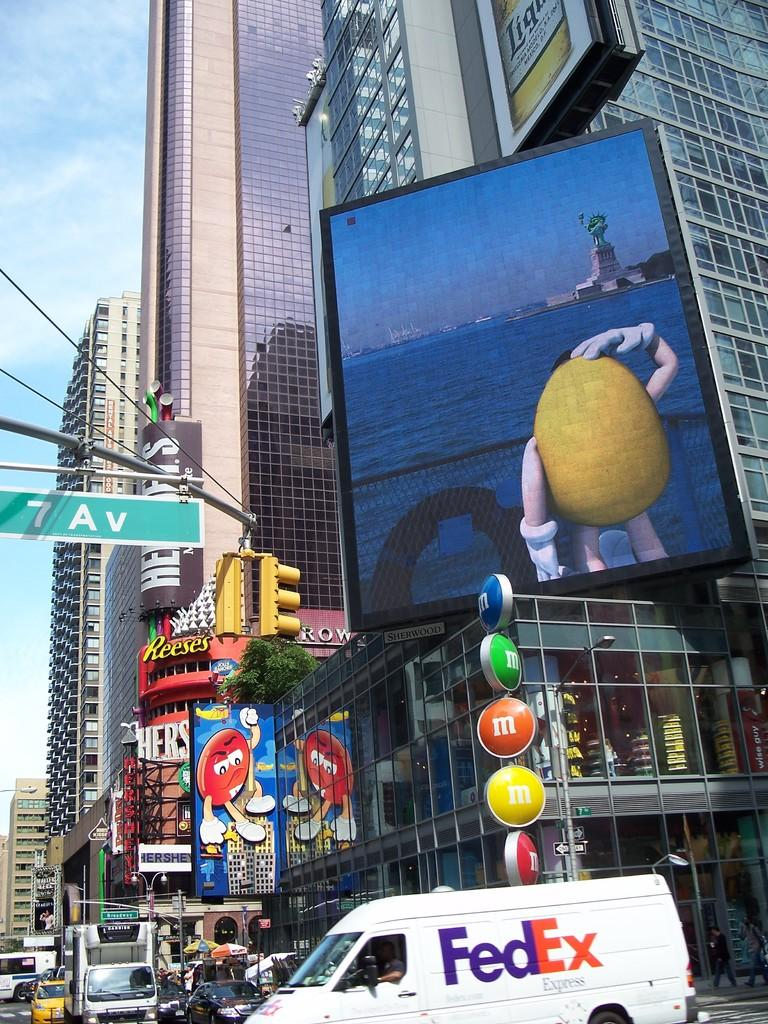<image>
Relay a brief, clear account of the picture shown. Busy street with tall skyscrapers and a Hershey's sign placed vertical on the building. 